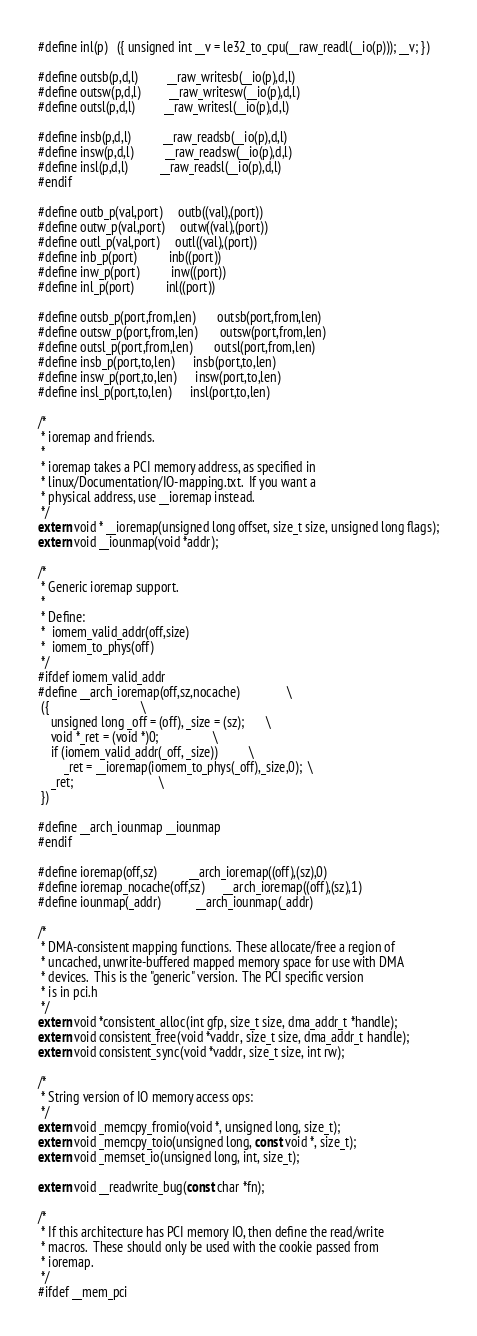Convert code to text. <code><loc_0><loc_0><loc_500><loc_500><_C_>#define inl(p)	({ unsigned int __v = le32_to_cpu(__raw_readl(__io(p))); __v; })

#define outsb(p,d,l)			__raw_writesb(__io(p),d,l)
#define outsw(p,d,l)			__raw_writesw(__io(p),d,l)
#define outsl(p,d,l)			__raw_writesl(__io(p),d,l)

#define insb(p,d,l)			__raw_readsb(__io(p),d,l)
#define insw(p,d,l)			__raw_readsw(__io(p),d,l)
#define insl(p,d,l)			__raw_readsl(__io(p),d,l)
#endif

#define outb_p(val,port)		outb((val),(port))
#define outw_p(val,port)		outw((val),(port))
#define outl_p(val,port)		outl((val),(port))
#define inb_p(port)			inb((port))
#define inw_p(port)			inw((port))
#define inl_p(port)			inl((port))

#define outsb_p(port,from,len)		outsb(port,from,len)
#define outsw_p(port,from,len)		outsw(port,from,len)
#define outsl_p(port,from,len)		outsl(port,from,len)
#define insb_p(port,to,len)		insb(port,to,len)
#define insw_p(port,to,len)		insw(port,to,len)
#define insl_p(port,to,len)		insl(port,to,len)

/*
 * ioremap and friends.
 *
 * ioremap takes a PCI memory address, as specified in
 * linux/Documentation/IO-mapping.txt.  If you want a
 * physical address, use __ioremap instead.
 */
extern void * __ioremap(unsigned long offset, size_t size, unsigned long flags);
extern void __iounmap(void *addr);

/*
 * Generic ioremap support.
 *
 * Define:
 *  iomem_valid_addr(off,size)
 *  iomem_to_phys(off)
 */
#ifdef iomem_valid_addr
#define __arch_ioremap(off,sz,nocache)				\
 ({								\
	unsigned long _off = (off), _size = (sz);		\
	void *_ret = (void *)0;					\
	if (iomem_valid_addr(_off, _size))			\
		_ret = __ioremap(iomem_to_phys(_off),_size,0);	\
	_ret;							\
 })

#define __arch_iounmap __iounmap
#endif

#define ioremap(off,sz)			__arch_ioremap((off),(sz),0)
#define ioremap_nocache(off,sz)		__arch_ioremap((off),(sz),1)
#define iounmap(_addr)			__arch_iounmap(_addr)

/*
 * DMA-consistent mapping functions.  These allocate/free a region of
 * uncached, unwrite-buffered mapped memory space for use with DMA
 * devices.  This is the "generic" version.  The PCI specific version
 * is in pci.h
 */
extern void *consistent_alloc(int gfp, size_t size, dma_addr_t *handle);
extern void consistent_free(void *vaddr, size_t size, dma_addr_t handle);
extern void consistent_sync(void *vaddr, size_t size, int rw);

/*
 * String version of IO memory access ops:
 */
extern void _memcpy_fromio(void *, unsigned long, size_t);
extern void _memcpy_toio(unsigned long, const void *, size_t);
extern void _memset_io(unsigned long, int, size_t);

extern void __readwrite_bug(const char *fn);

/*
 * If this architecture has PCI memory IO, then define the read/write
 * macros.  These should only be used with the cookie passed from
 * ioremap.
 */
#ifdef __mem_pci
</code> 